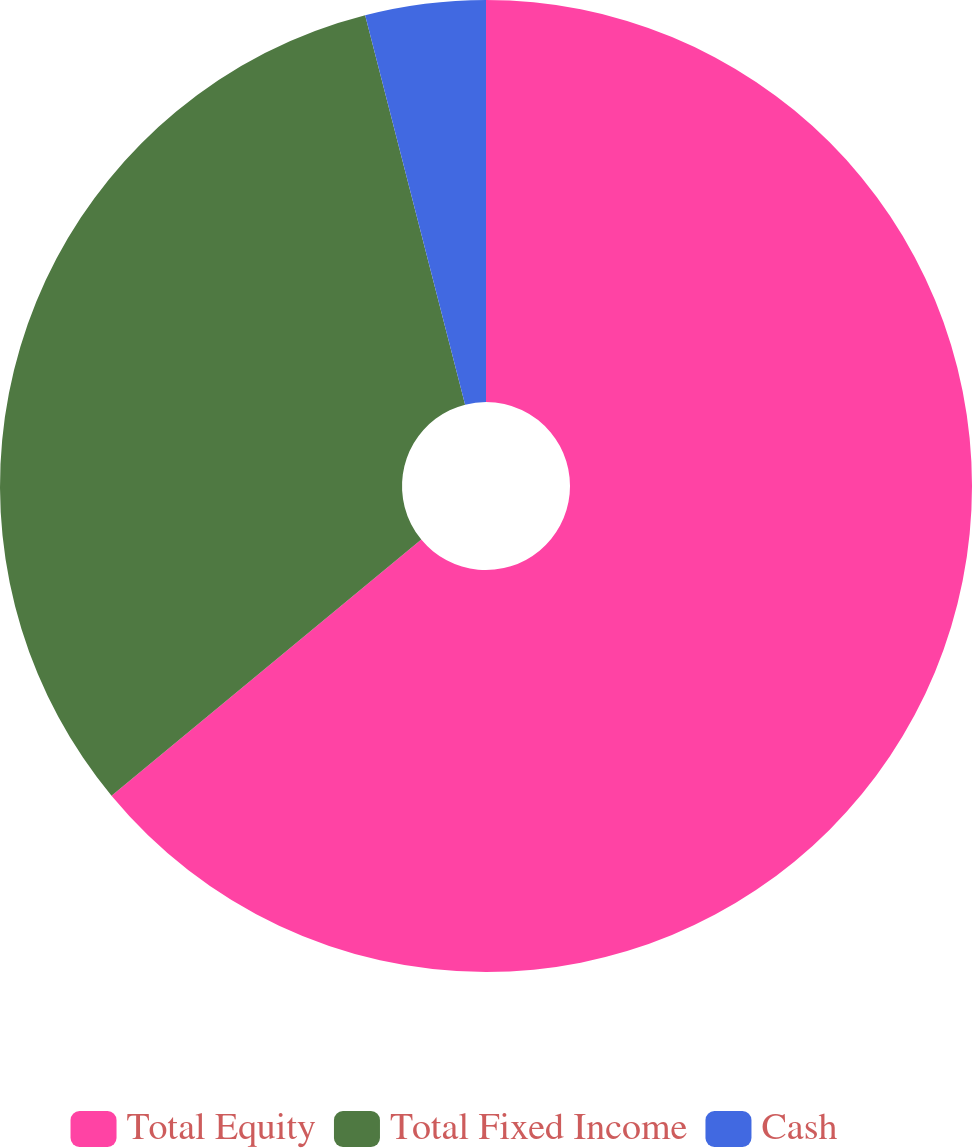Convert chart to OTSL. <chart><loc_0><loc_0><loc_500><loc_500><pie_chart><fcel>Total Equity<fcel>Total Fixed Income<fcel>Cash<nl><fcel>64.0%<fcel>32.0%<fcel>4.0%<nl></chart> 